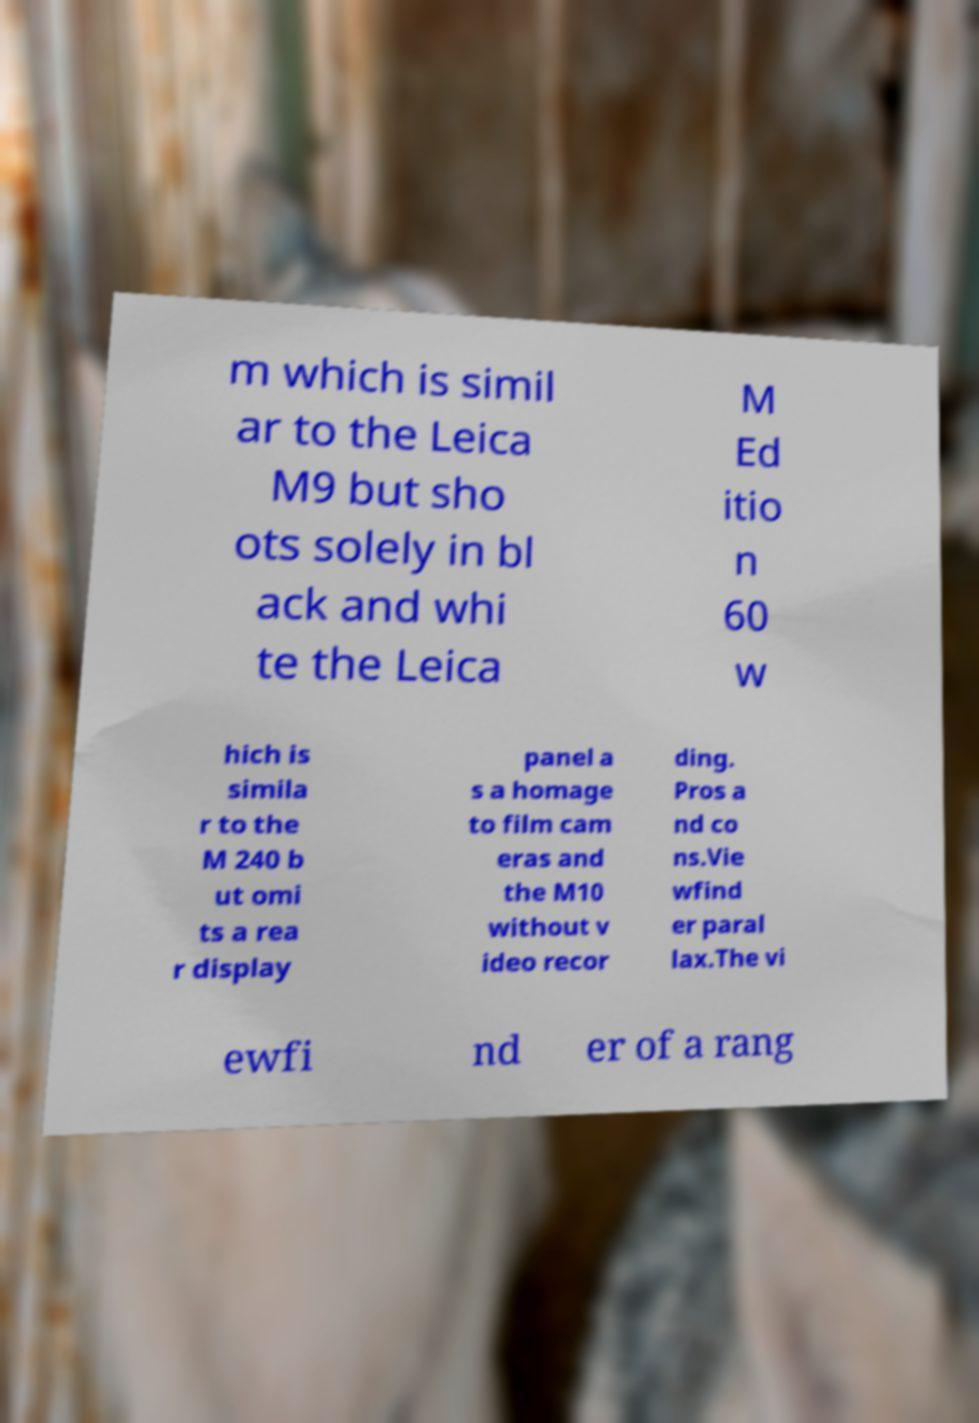There's text embedded in this image that I need extracted. Can you transcribe it verbatim? m which is simil ar to the Leica M9 but sho ots solely in bl ack and whi te the Leica M Ed itio n 60 w hich is simila r to the M 240 b ut omi ts a rea r display panel a s a homage to film cam eras and the M10 without v ideo recor ding. Pros a nd co ns.Vie wfind er paral lax.The vi ewfi nd er of a rang 